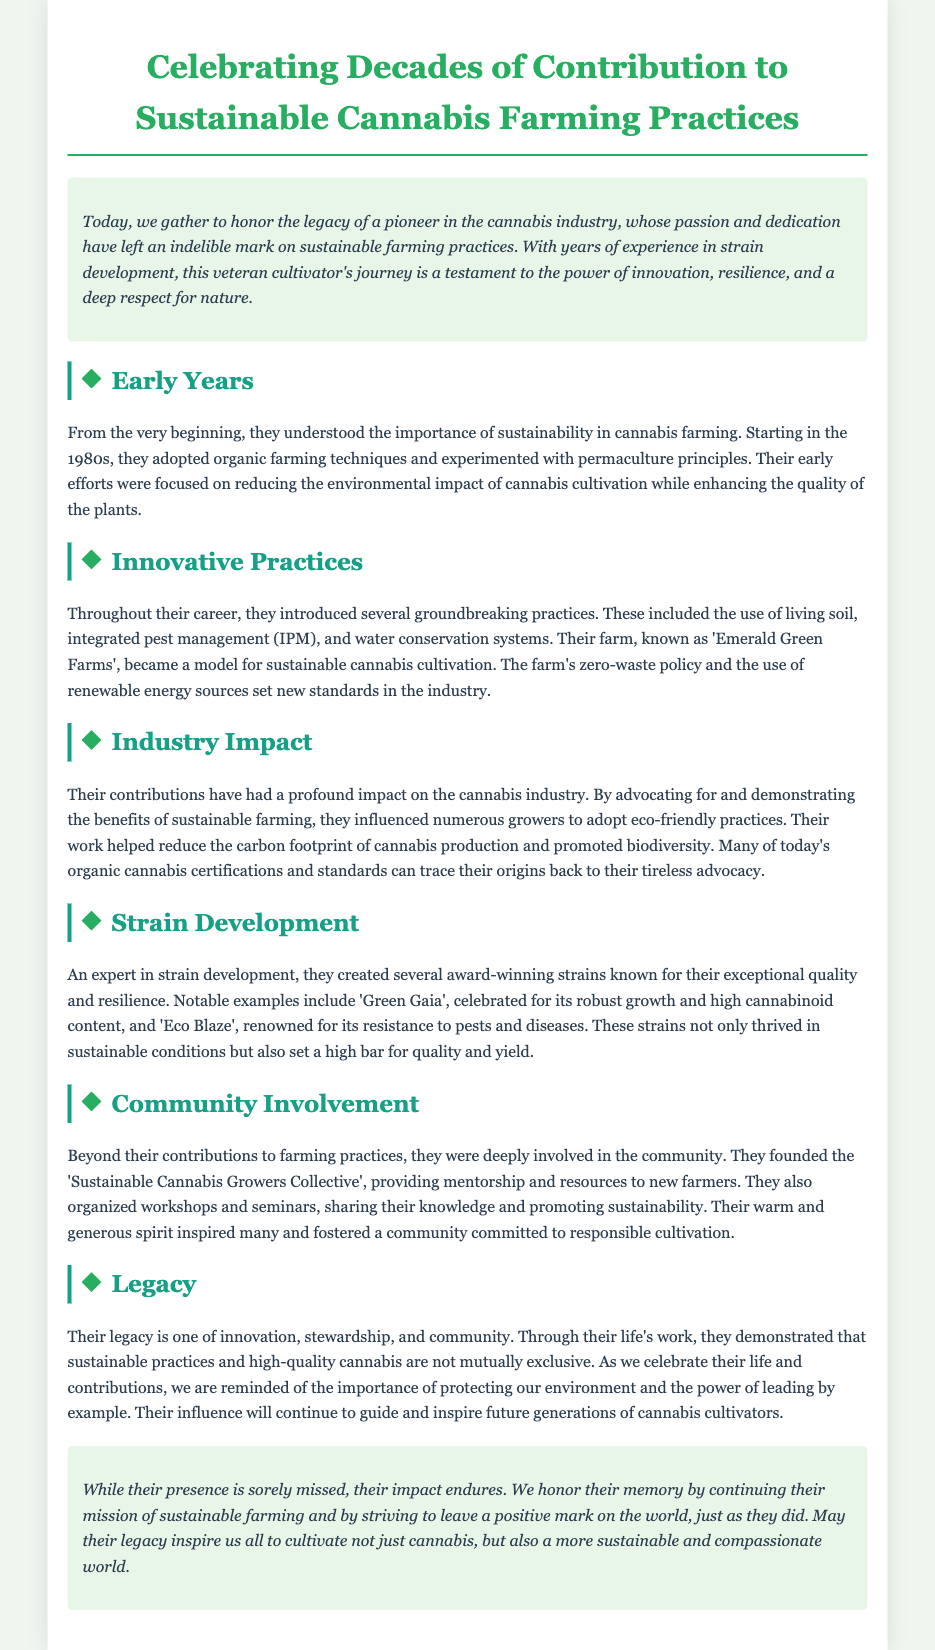What decade did the honoree start their cannabis farming journey? The document states they began their journey in the 1980s, making this the answer.
Answer: 1980s What is the name of the honoree's farm? The farm is referred to as 'Emerald Green Farms' in the document.
Answer: Emerald Green Farms Which two strains were created by the honoree? The document mentions 'Green Gaia' and 'Eco Blaze' as notable strains developed by the honoree.
Answer: Green Gaia, Eco Blaze What farming technique did the honoree adopt from the start? The document states that they understood the importance of sustainability, adopting organic farming techniques early on.
Answer: Organic farming techniques What type of community initiative did the honoree found? The document describes the 'Sustainable Cannabis Growers Collective' as an initiative founded by the honoree.
Answer: Sustainable Cannabis Growers Collective What is emphasized as part of the honoree's legacy? The document highlights that their legacy is one of innovation, stewardship, and community.
Answer: Innovation, stewardship, and community How did the honoree influence sustainable cannabis farming? The honoree advocated for eco-friendly practices and demonstrated their benefits, influencing numerous growers.
Answer: Advocating for eco-friendly practices What is described as a profound impact on the industry? The document mentions the reduction of carbon footprint and promotion of biodiversity as profound impacts of the honoree's contributions.
Answer: Reduction of carbon footprint, promotion of biodiversity 